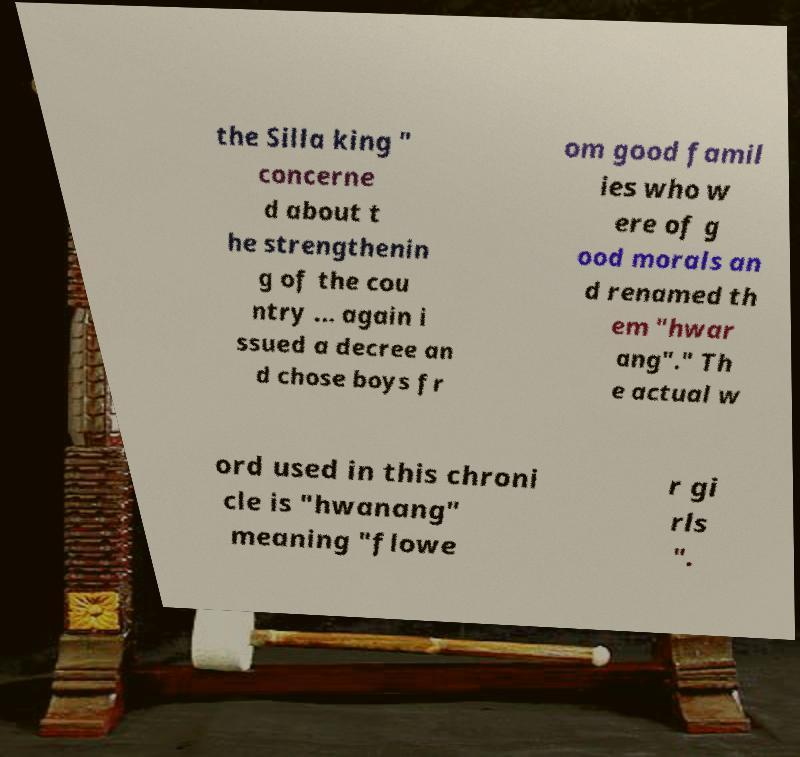Can you read and provide the text displayed in the image?This photo seems to have some interesting text. Can you extract and type it out for me? the Silla king " concerne d about t he strengthenin g of the cou ntry ... again i ssued a decree an d chose boys fr om good famil ies who w ere of g ood morals an d renamed th em "hwar ang"." Th e actual w ord used in this chroni cle is "hwanang" meaning "flowe r gi rls ". 